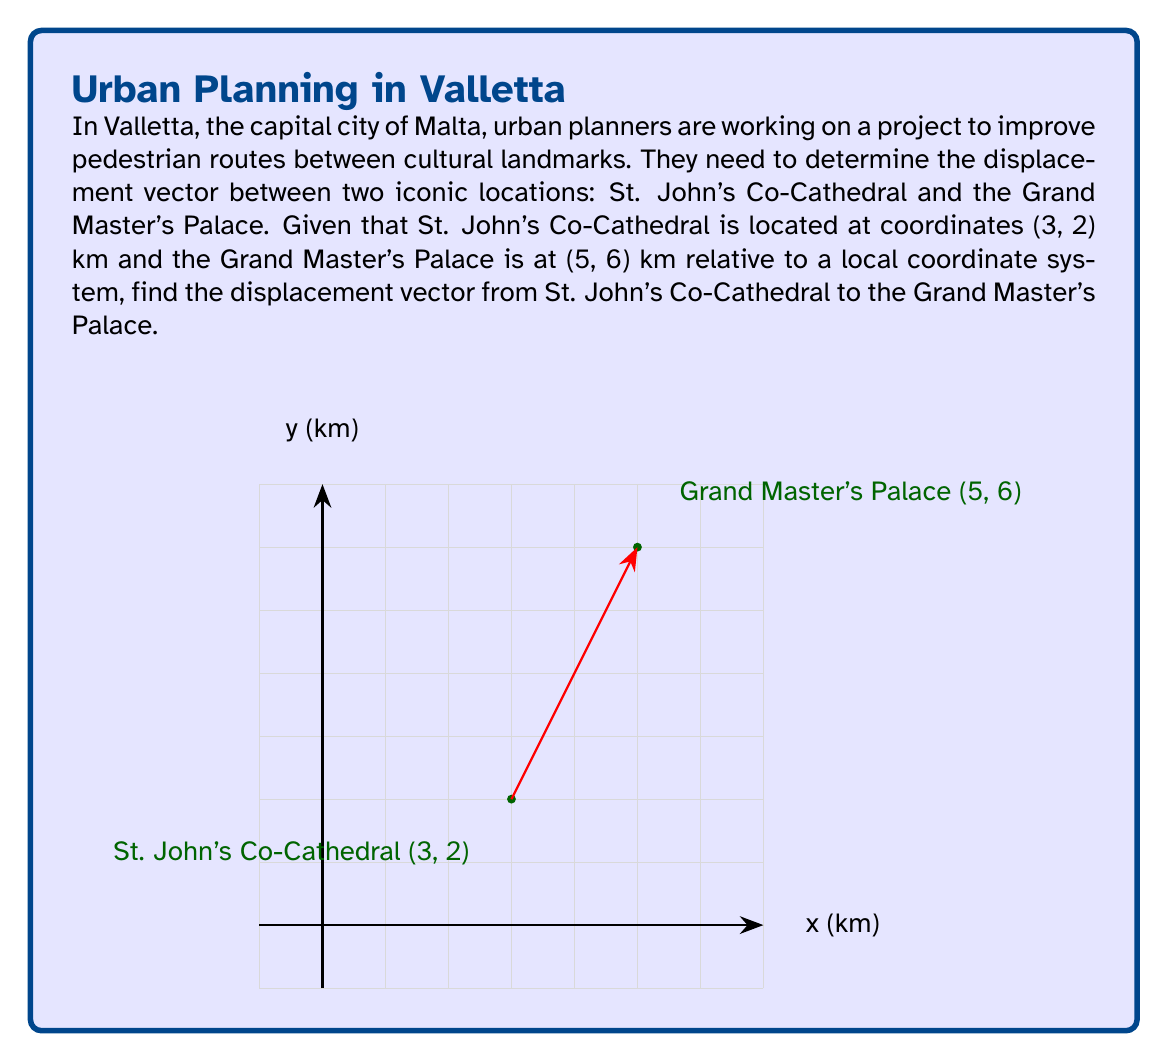Teach me how to tackle this problem. To find the displacement vector between two points, we need to subtract the coordinates of the starting point from the coordinates of the ending point. Let's approach this step-by-step:

1. Identify the coordinates:
   - St. John's Co-Cathedral: $A(3, 2)$
   - Grand Master's Palace: $B(5, 6)$

2. Calculate the displacement vector $\vec{AB}$:
   $$\vec{AB} = B - A = (x_B - x_A, y_B - y_A)$$

3. Substitute the values:
   $$\vec{AB} = (5 - 3, 6 - 2)$$

4. Perform the subtraction:
   $$\vec{AB} = (2, 4)$$

5. Interpret the result:
   The displacement vector $(2, 4)$ means that to get from St. John's Co-Cathedral to the Grand Master's Palace, one needs to move 2 km in the positive x-direction (east) and 4 km in the positive y-direction (north).

6. The magnitude of this vector can be calculated using the Pythagorean theorem:
   $$|\vec{AB}| = \sqrt{2^2 + 4^2} = \sqrt{4 + 16} = \sqrt{20} \approx 4.47 \text{ km}$$

This represents the straight-line distance between the two landmarks.
Answer: $\vec{AB} = (2, 4)$ km 